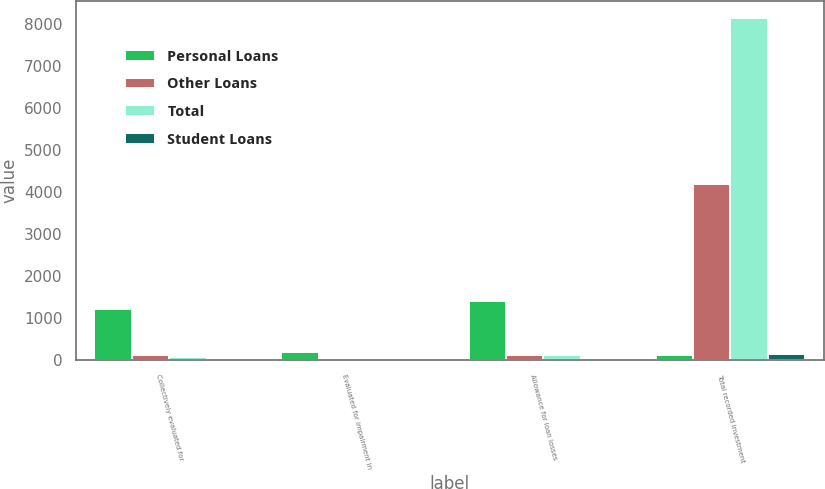Convert chart to OTSL. <chart><loc_0><loc_0><loc_500><loc_500><stacked_bar_chart><ecel><fcel>Collectively evaluated for<fcel>Evaluated for impairment in<fcel>Allowance for loan losses<fcel>Total recorded investment<nl><fcel>Personal Loans<fcel>1218<fcel>188<fcel>1406<fcel>112<nl><fcel>Other Loans<fcel>109<fcel>3<fcel>112<fcel>4191<nl><fcel>Total<fcel>76<fcel>9<fcel>113<fcel>8147<nl><fcel>Student Loans<fcel>1<fcel>16<fcel>17<fcel>135<nl></chart> 